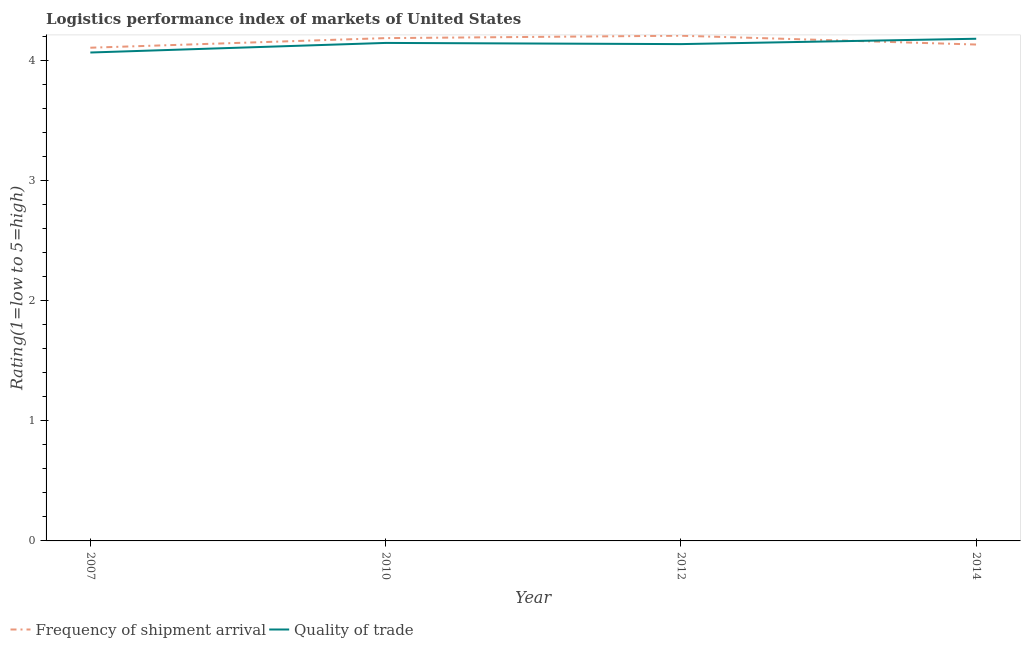Does the line corresponding to lpi of frequency of shipment arrival intersect with the line corresponding to lpi quality of trade?
Provide a succinct answer. Yes. What is the lpi of frequency of shipment arrival in 2014?
Provide a succinct answer. 4.14. Across all years, what is the maximum lpi of frequency of shipment arrival?
Make the answer very short. 4.21. Across all years, what is the minimum lpi quality of trade?
Offer a terse response. 4.07. In which year was the lpi quality of trade maximum?
Give a very brief answer. 2014. What is the total lpi quality of trade in the graph?
Offer a terse response. 16.54. What is the difference between the lpi quality of trade in 2010 and that in 2014?
Provide a short and direct response. -0.03. What is the difference between the lpi of frequency of shipment arrival in 2014 and the lpi quality of trade in 2010?
Provide a short and direct response. -0.01. What is the average lpi quality of trade per year?
Ensure brevity in your answer.  4.14. In the year 2010, what is the difference between the lpi of frequency of shipment arrival and lpi quality of trade?
Your answer should be very brief. 0.04. In how many years, is the lpi quality of trade greater than 3.2?
Your answer should be compact. 4. What is the ratio of the lpi quality of trade in 2007 to that in 2014?
Make the answer very short. 0.97. Is the difference between the lpi of frequency of shipment arrival in 2010 and 2012 greater than the difference between the lpi quality of trade in 2010 and 2012?
Offer a terse response. No. What is the difference between the highest and the second highest lpi quality of trade?
Make the answer very short. 0.03. What is the difference between the highest and the lowest lpi quality of trade?
Keep it short and to the point. 0.11. In how many years, is the lpi of frequency of shipment arrival greater than the average lpi of frequency of shipment arrival taken over all years?
Your response must be concise. 2. Does the lpi quality of trade monotonically increase over the years?
Your answer should be very brief. No. Is the lpi of frequency of shipment arrival strictly greater than the lpi quality of trade over the years?
Keep it short and to the point. No. How many lines are there?
Make the answer very short. 2. What is the difference between two consecutive major ticks on the Y-axis?
Your answer should be very brief. 1. Does the graph contain grids?
Your answer should be very brief. No. Where does the legend appear in the graph?
Your answer should be very brief. Bottom left. What is the title of the graph?
Keep it short and to the point. Logistics performance index of markets of United States. What is the label or title of the X-axis?
Provide a short and direct response. Year. What is the label or title of the Y-axis?
Make the answer very short. Rating(1=low to 5=high). What is the Rating(1=low to 5=high) in Frequency of shipment arrival in 2007?
Provide a succinct answer. 4.11. What is the Rating(1=low to 5=high) in Quality of trade in 2007?
Your response must be concise. 4.07. What is the Rating(1=low to 5=high) of Frequency of shipment arrival in 2010?
Offer a terse response. 4.19. What is the Rating(1=low to 5=high) in Quality of trade in 2010?
Your response must be concise. 4.15. What is the Rating(1=low to 5=high) of Frequency of shipment arrival in 2012?
Offer a very short reply. 4.21. What is the Rating(1=low to 5=high) of Quality of trade in 2012?
Offer a very short reply. 4.14. What is the Rating(1=low to 5=high) of Frequency of shipment arrival in 2014?
Make the answer very short. 4.14. What is the Rating(1=low to 5=high) of Quality of trade in 2014?
Make the answer very short. 4.18. Across all years, what is the maximum Rating(1=low to 5=high) of Frequency of shipment arrival?
Make the answer very short. 4.21. Across all years, what is the maximum Rating(1=low to 5=high) in Quality of trade?
Make the answer very short. 4.18. Across all years, what is the minimum Rating(1=low to 5=high) of Frequency of shipment arrival?
Offer a terse response. 4.11. Across all years, what is the minimum Rating(1=low to 5=high) in Quality of trade?
Provide a short and direct response. 4.07. What is the total Rating(1=low to 5=high) of Frequency of shipment arrival in the graph?
Make the answer very short. 16.65. What is the total Rating(1=low to 5=high) of Quality of trade in the graph?
Give a very brief answer. 16.54. What is the difference between the Rating(1=low to 5=high) of Frequency of shipment arrival in 2007 and that in 2010?
Offer a terse response. -0.08. What is the difference between the Rating(1=low to 5=high) in Quality of trade in 2007 and that in 2010?
Your response must be concise. -0.08. What is the difference between the Rating(1=low to 5=high) in Quality of trade in 2007 and that in 2012?
Your answer should be very brief. -0.07. What is the difference between the Rating(1=low to 5=high) of Frequency of shipment arrival in 2007 and that in 2014?
Give a very brief answer. -0.03. What is the difference between the Rating(1=low to 5=high) in Quality of trade in 2007 and that in 2014?
Keep it short and to the point. -0.11. What is the difference between the Rating(1=low to 5=high) in Frequency of shipment arrival in 2010 and that in 2012?
Your answer should be very brief. -0.02. What is the difference between the Rating(1=low to 5=high) in Frequency of shipment arrival in 2010 and that in 2014?
Make the answer very short. 0.05. What is the difference between the Rating(1=low to 5=high) of Quality of trade in 2010 and that in 2014?
Provide a short and direct response. -0.03. What is the difference between the Rating(1=low to 5=high) of Frequency of shipment arrival in 2012 and that in 2014?
Keep it short and to the point. 0.07. What is the difference between the Rating(1=low to 5=high) of Quality of trade in 2012 and that in 2014?
Make the answer very short. -0.04. What is the difference between the Rating(1=low to 5=high) of Frequency of shipment arrival in 2007 and the Rating(1=low to 5=high) of Quality of trade in 2010?
Your answer should be very brief. -0.04. What is the difference between the Rating(1=low to 5=high) of Frequency of shipment arrival in 2007 and the Rating(1=low to 5=high) of Quality of trade in 2012?
Make the answer very short. -0.03. What is the difference between the Rating(1=low to 5=high) of Frequency of shipment arrival in 2007 and the Rating(1=low to 5=high) of Quality of trade in 2014?
Ensure brevity in your answer.  -0.07. What is the difference between the Rating(1=low to 5=high) in Frequency of shipment arrival in 2010 and the Rating(1=low to 5=high) in Quality of trade in 2014?
Offer a terse response. 0.01. What is the difference between the Rating(1=low to 5=high) of Frequency of shipment arrival in 2012 and the Rating(1=low to 5=high) of Quality of trade in 2014?
Make the answer very short. 0.03. What is the average Rating(1=low to 5=high) in Frequency of shipment arrival per year?
Make the answer very short. 4.16. What is the average Rating(1=low to 5=high) in Quality of trade per year?
Your response must be concise. 4.14. In the year 2007, what is the difference between the Rating(1=low to 5=high) in Frequency of shipment arrival and Rating(1=low to 5=high) in Quality of trade?
Make the answer very short. 0.04. In the year 2010, what is the difference between the Rating(1=low to 5=high) of Frequency of shipment arrival and Rating(1=low to 5=high) of Quality of trade?
Make the answer very short. 0.04. In the year 2012, what is the difference between the Rating(1=low to 5=high) in Frequency of shipment arrival and Rating(1=low to 5=high) in Quality of trade?
Your response must be concise. 0.07. In the year 2014, what is the difference between the Rating(1=low to 5=high) in Frequency of shipment arrival and Rating(1=low to 5=high) in Quality of trade?
Offer a terse response. -0.05. What is the ratio of the Rating(1=low to 5=high) in Frequency of shipment arrival in 2007 to that in 2010?
Provide a short and direct response. 0.98. What is the ratio of the Rating(1=low to 5=high) of Quality of trade in 2007 to that in 2010?
Provide a succinct answer. 0.98. What is the ratio of the Rating(1=low to 5=high) in Frequency of shipment arrival in 2007 to that in 2012?
Give a very brief answer. 0.98. What is the ratio of the Rating(1=low to 5=high) in Quality of trade in 2007 to that in 2012?
Provide a succinct answer. 0.98. What is the ratio of the Rating(1=low to 5=high) of Frequency of shipment arrival in 2007 to that in 2014?
Your answer should be compact. 0.99. What is the ratio of the Rating(1=low to 5=high) in Quality of trade in 2007 to that in 2014?
Your response must be concise. 0.97. What is the ratio of the Rating(1=low to 5=high) of Frequency of shipment arrival in 2010 to that in 2012?
Provide a succinct answer. 1. What is the ratio of the Rating(1=low to 5=high) of Frequency of shipment arrival in 2010 to that in 2014?
Your response must be concise. 1.01. What is the ratio of the Rating(1=low to 5=high) of Quality of trade in 2010 to that in 2014?
Provide a succinct answer. 0.99. What is the ratio of the Rating(1=low to 5=high) of Frequency of shipment arrival in 2012 to that in 2014?
Your answer should be very brief. 1.02. What is the ratio of the Rating(1=low to 5=high) in Quality of trade in 2012 to that in 2014?
Ensure brevity in your answer.  0.99. What is the difference between the highest and the second highest Rating(1=low to 5=high) in Frequency of shipment arrival?
Give a very brief answer. 0.02. What is the difference between the highest and the second highest Rating(1=low to 5=high) in Quality of trade?
Offer a very short reply. 0.03. What is the difference between the highest and the lowest Rating(1=low to 5=high) in Quality of trade?
Your response must be concise. 0.11. 